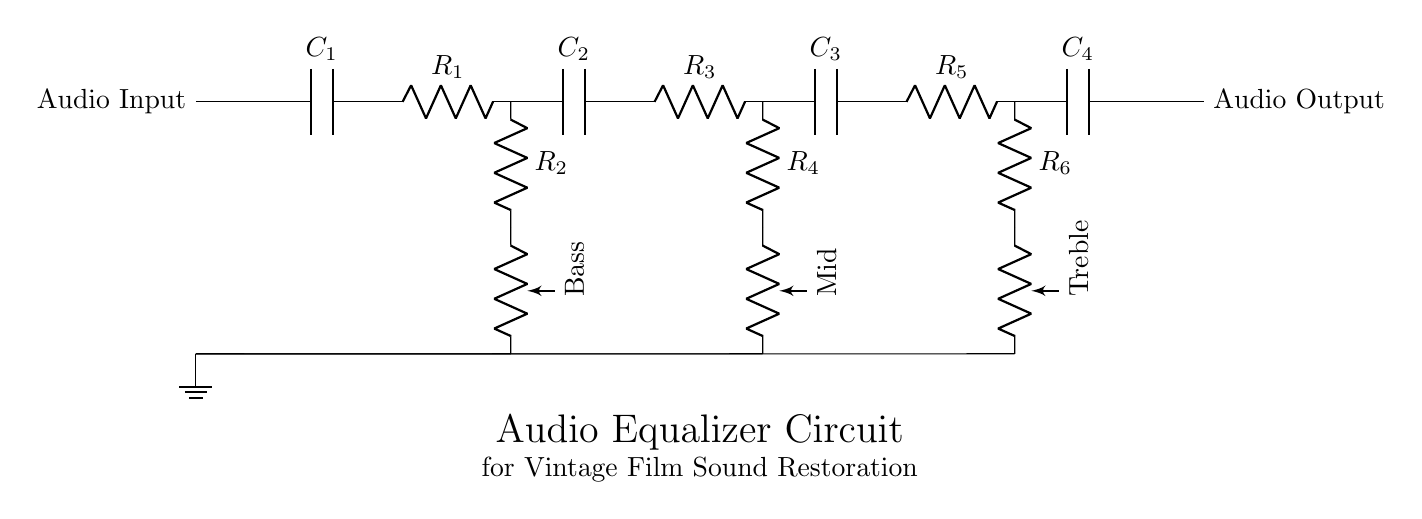What is the input component in this circuit? The input component is a capacitor labeled C1 that allows the audio signal to enter the circuit while blocking DC voltage.
Answer: C1 What type of control is used for bass adjustment? The bass adjustment is done using a potentiometer connected to resistor R2, allowing variable resistance to control the low-frequency signal.
Answer: Potentiometer Which components are used for mid-frequency adjustment? The mid-frequency adjustment uses resistor R4 and a potentiometer labeled Mid, facilitating the control of mid-range audio frequencies.
Answer: R4 and Mid potentiometer How many capacitors are present in the circuit? There are four capacitors (C1, C2, C3, C4) included in the circuit design, each serving different frequency control stages.
Answer: Four What is the purpose of the output in this circuit? The output allows the processed audio signal to be sent out from the circuit as audio output after equalization has occurred, ensuring the final sound is tailored.
Answer: Audio Output Which stage has the highest frequency control? The high-frequency stage is represented by resistor R6 and capacitor C4, dedicated to adjusting the treble frequencies in the audio signal.
Answer: Treble stage (R6 and C4) What is a primary difference between the low-frequency and high-frequency stages? The primary difference lies in the types of potentiometers used; the low-frequency stage uses a potentiometer for Bass, while the high-frequency stage uses one for Treble, each affecting different ranges of sound.
Answer: Potentiometers (Bass vs. Treble) 